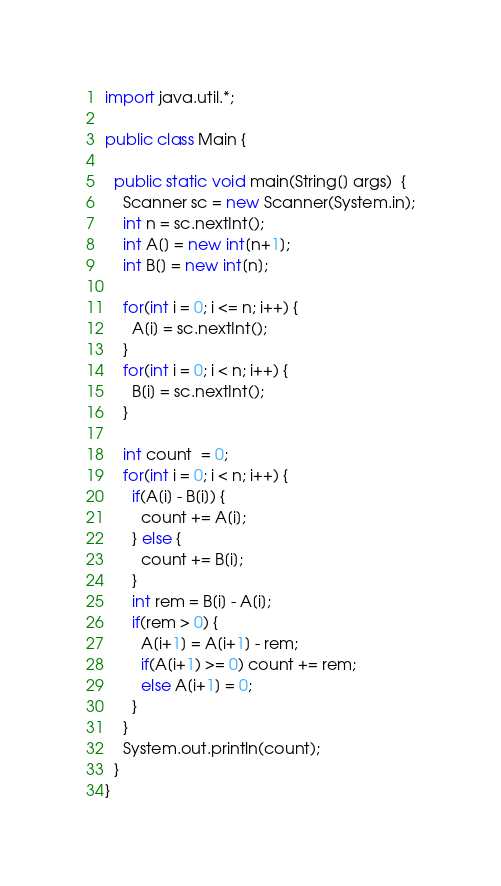Convert code to text. <code><loc_0><loc_0><loc_500><loc_500><_Java_>import java.util.*;
 
public class Main {
  
  public static void main(String[] args)  {
    Scanner sc = new Scanner(System.in);
    int n = sc.nextInt();
    int A[] = new int[n+1];
    int B[] = new int[n];
    
    for(int i = 0; i <= n; i++) {
      A[i] = sc.nextInt();
    }
    for(int i = 0; i < n; i++) {
      B[i] = sc.nextInt();
    }
    
    int count  = 0;
    for(int i = 0; i < n; i++) {
      if(A[i] - B[i]) {
        count += A[i];
      } else {
        count += B[i];
      }
      int rem = B[i] - A[i];
      if(rem > 0) {
        A[i+1] = A[i+1] - rem;
        if(A[i+1) >= 0) count += rem;
        else A[i+1] = 0;     
      }
    }
    System.out.println(count);
  }
}</code> 